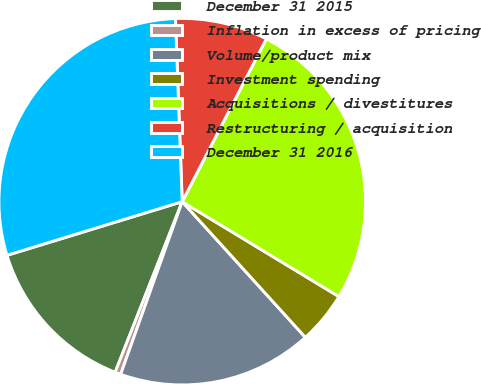Convert chart. <chart><loc_0><loc_0><loc_500><loc_500><pie_chart><fcel>December 31 2015<fcel>Inflation in excess of pricing<fcel>Volume/product mix<fcel>Investment spending<fcel>Acquisitions / divestitures<fcel>Restructuring / acquisition<fcel>December 31 2016<nl><fcel>14.31%<fcel>0.51%<fcel>17.18%<fcel>4.6%<fcel>26.07%<fcel>8.18%<fcel>29.14%<nl></chart> 